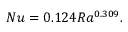<formula> <loc_0><loc_0><loc_500><loc_500>N u = 0 . 1 2 4 R a ^ { 0 . 3 0 9 } .</formula> 